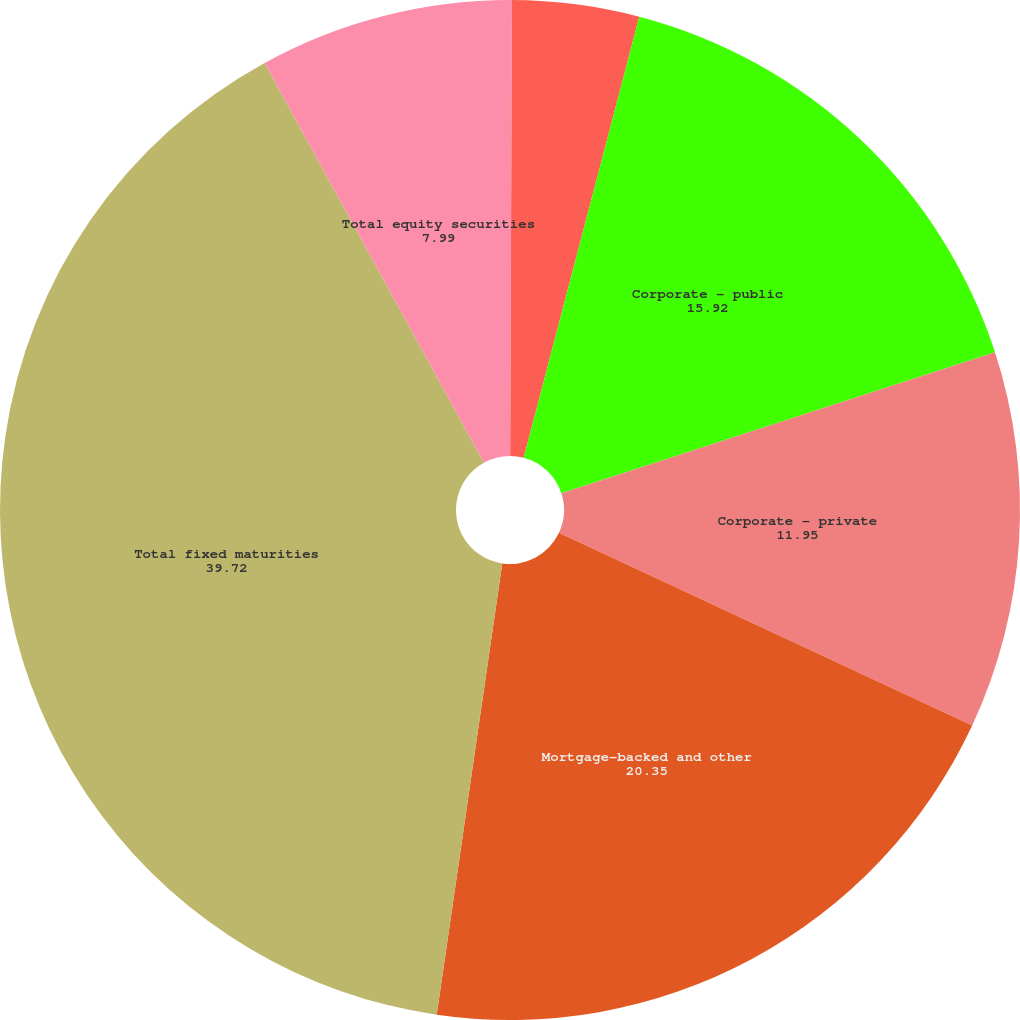Convert chart to OTSL. <chart><loc_0><loc_0><loc_500><loc_500><pie_chart><fcel>Non-US governments<fcel>States and political<fcel>Corporate - public<fcel>Corporate - private<fcel>Mortgage-backed and other<fcel>Total fixed maturities<fcel>Total equity securities<nl><fcel>0.06%<fcel>4.02%<fcel>15.92%<fcel>11.95%<fcel>20.35%<fcel>39.72%<fcel>7.99%<nl></chart> 